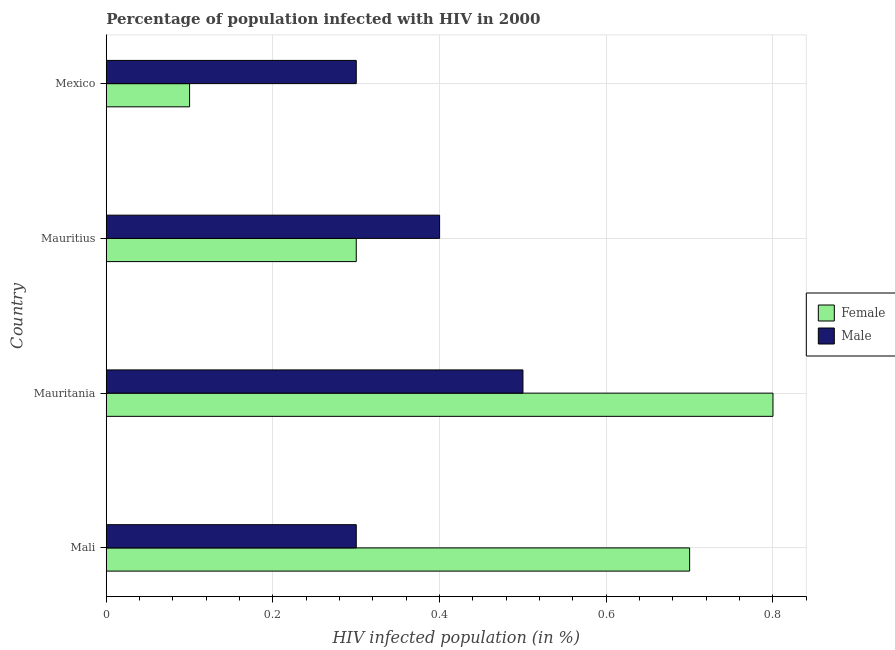How many different coloured bars are there?
Your answer should be compact. 2. Are the number of bars on each tick of the Y-axis equal?
Keep it short and to the point. Yes. What is the label of the 3rd group of bars from the top?
Your answer should be very brief. Mauritania. What is the percentage of males who are infected with hiv in Mauritania?
Give a very brief answer. 0.5. Across all countries, what is the minimum percentage of males who are infected with hiv?
Provide a short and direct response. 0.3. In which country was the percentage of females who are infected with hiv maximum?
Your answer should be compact. Mauritania. In which country was the percentage of males who are infected with hiv minimum?
Provide a succinct answer. Mali. What is the total percentage of females who are infected with hiv in the graph?
Provide a succinct answer. 1.9. What is the difference between the percentage of males who are infected with hiv in Mauritania and that in Mauritius?
Offer a very short reply. 0.1. What is the difference between the percentage of females who are infected with hiv in Mauritius and the percentage of males who are infected with hiv in Mauritania?
Make the answer very short. -0.2. What is the average percentage of males who are infected with hiv per country?
Offer a very short reply. 0.38. In how many countries, is the percentage of males who are infected with hiv greater than 0.8 %?
Offer a very short reply. 0. What is the ratio of the percentage of males who are infected with hiv in Mauritius to that in Mexico?
Provide a succinct answer. 1.33. Is the difference between the percentage of males who are infected with hiv in Mauritania and Mauritius greater than the difference between the percentage of females who are infected with hiv in Mauritania and Mauritius?
Your response must be concise. No. What is the difference between the highest and the second highest percentage of males who are infected with hiv?
Give a very brief answer. 0.1. What is the difference between the highest and the lowest percentage of females who are infected with hiv?
Provide a short and direct response. 0.7. Is the sum of the percentage of females who are infected with hiv in Mauritania and Mexico greater than the maximum percentage of males who are infected with hiv across all countries?
Ensure brevity in your answer.  Yes. What does the 1st bar from the top in Mali represents?
Offer a terse response. Male. Are all the bars in the graph horizontal?
Give a very brief answer. Yes. Does the graph contain grids?
Offer a very short reply. Yes. How many legend labels are there?
Ensure brevity in your answer.  2. How are the legend labels stacked?
Your response must be concise. Vertical. What is the title of the graph?
Your response must be concise. Percentage of population infected with HIV in 2000. Does "From World Bank" appear as one of the legend labels in the graph?
Offer a terse response. No. What is the label or title of the X-axis?
Your response must be concise. HIV infected population (in %). What is the HIV infected population (in %) in Female in Mali?
Offer a terse response. 0.7. What is the HIV infected population (in %) of Male in Mauritius?
Ensure brevity in your answer.  0.4. What is the HIV infected population (in %) of Female in Mexico?
Keep it short and to the point. 0.1. What is the HIV infected population (in %) of Male in Mexico?
Make the answer very short. 0.3. Across all countries, what is the maximum HIV infected population (in %) in Female?
Your answer should be very brief. 0.8. What is the difference between the HIV infected population (in %) of Female in Mali and that in Mauritania?
Offer a terse response. -0.1. What is the difference between the HIV infected population (in %) in Male in Mali and that in Mauritania?
Give a very brief answer. -0.2. What is the difference between the HIV infected population (in %) in Male in Mali and that in Mexico?
Provide a short and direct response. 0. What is the difference between the HIV infected population (in %) of Female in Mauritania and that in Mauritius?
Give a very brief answer. 0.5. What is the difference between the HIV infected population (in %) of Female in Mauritania and that in Mexico?
Provide a succinct answer. 0.7. What is the difference between the HIV infected population (in %) of Male in Mauritania and that in Mexico?
Ensure brevity in your answer.  0.2. What is the difference between the HIV infected population (in %) in Male in Mauritius and that in Mexico?
Your response must be concise. 0.1. What is the difference between the HIV infected population (in %) in Female in Mali and the HIV infected population (in %) in Male in Mexico?
Ensure brevity in your answer.  0.4. What is the difference between the HIV infected population (in %) of Female in Mauritania and the HIV infected population (in %) of Male in Mauritius?
Make the answer very short. 0.4. What is the difference between the HIV infected population (in %) in Female in Mauritania and the HIV infected population (in %) in Male in Mexico?
Ensure brevity in your answer.  0.5. What is the average HIV infected population (in %) of Female per country?
Ensure brevity in your answer.  0.47. What is the difference between the HIV infected population (in %) in Female and HIV infected population (in %) in Male in Mali?
Provide a succinct answer. 0.4. What is the difference between the HIV infected population (in %) in Female and HIV infected population (in %) in Male in Mauritius?
Offer a terse response. -0.1. What is the difference between the HIV infected population (in %) in Female and HIV infected population (in %) in Male in Mexico?
Your response must be concise. -0.2. What is the ratio of the HIV infected population (in %) in Female in Mali to that in Mauritania?
Your answer should be very brief. 0.88. What is the ratio of the HIV infected population (in %) of Female in Mali to that in Mauritius?
Your response must be concise. 2.33. What is the ratio of the HIV infected population (in %) of Female in Mali to that in Mexico?
Your response must be concise. 7. What is the ratio of the HIV infected population (in %) of Female in Mauritania to that in Mauritius?
Make the answer very short. 2.67. What is the ratio of the HIV infected population (in %) of Male in Mauritania to that in Mexico?
Make the answer very short. 1.67. What is the ratio of the HIV infected population (in %) of Female in Mauritius to that in Mexico?
Offer a very short reply. 3. What is the ratio of the HIV infected population (in %) of Male in Mauritius to that in Mexico?
Your answer should be compact. 1.33. What is the difference between the highest and the lowest HIV infected population (in %) in Female?
Your answer should be compact. 0.7. What is the difference between the highest and the lowest HIV infected population (in %) in Male?
Offer a terse response. 0.2. 